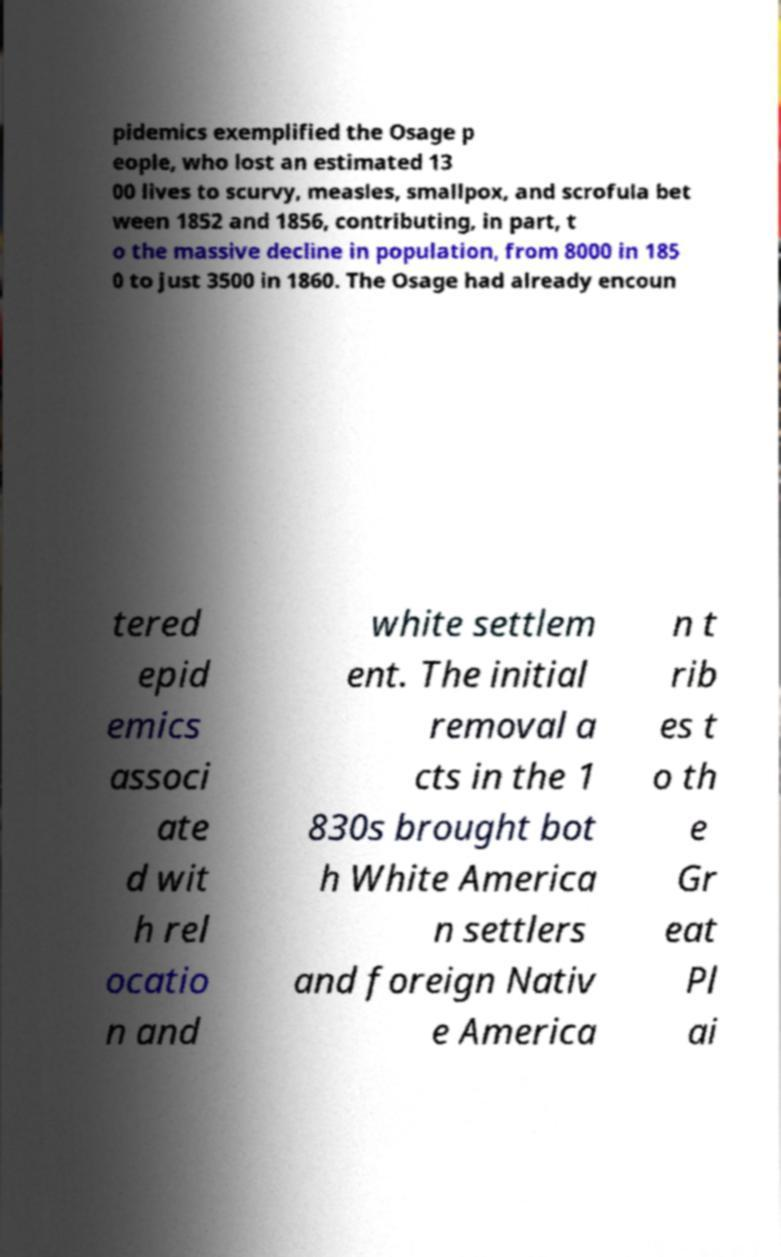Please read and relay the text visible in this image. What does it say? pidemics exemplified the Osage p eople, who lost an estimated 13 00 lives to scurvy, measles, smallpox, and scrofula bet ween 1852 and 1856, contributing, in part, t o the massive decline in population, from 8000 in 185 0 to just 3500 in 1860. The Osage had already encoun tered epid emics associ ate d wit h rel ocatio n and white settlem ent. The initial removal a cts in the 1 830s brought bot h White America n settlers and foreign Nativ e America n t rib es t o th e Gr eat Pl ai 